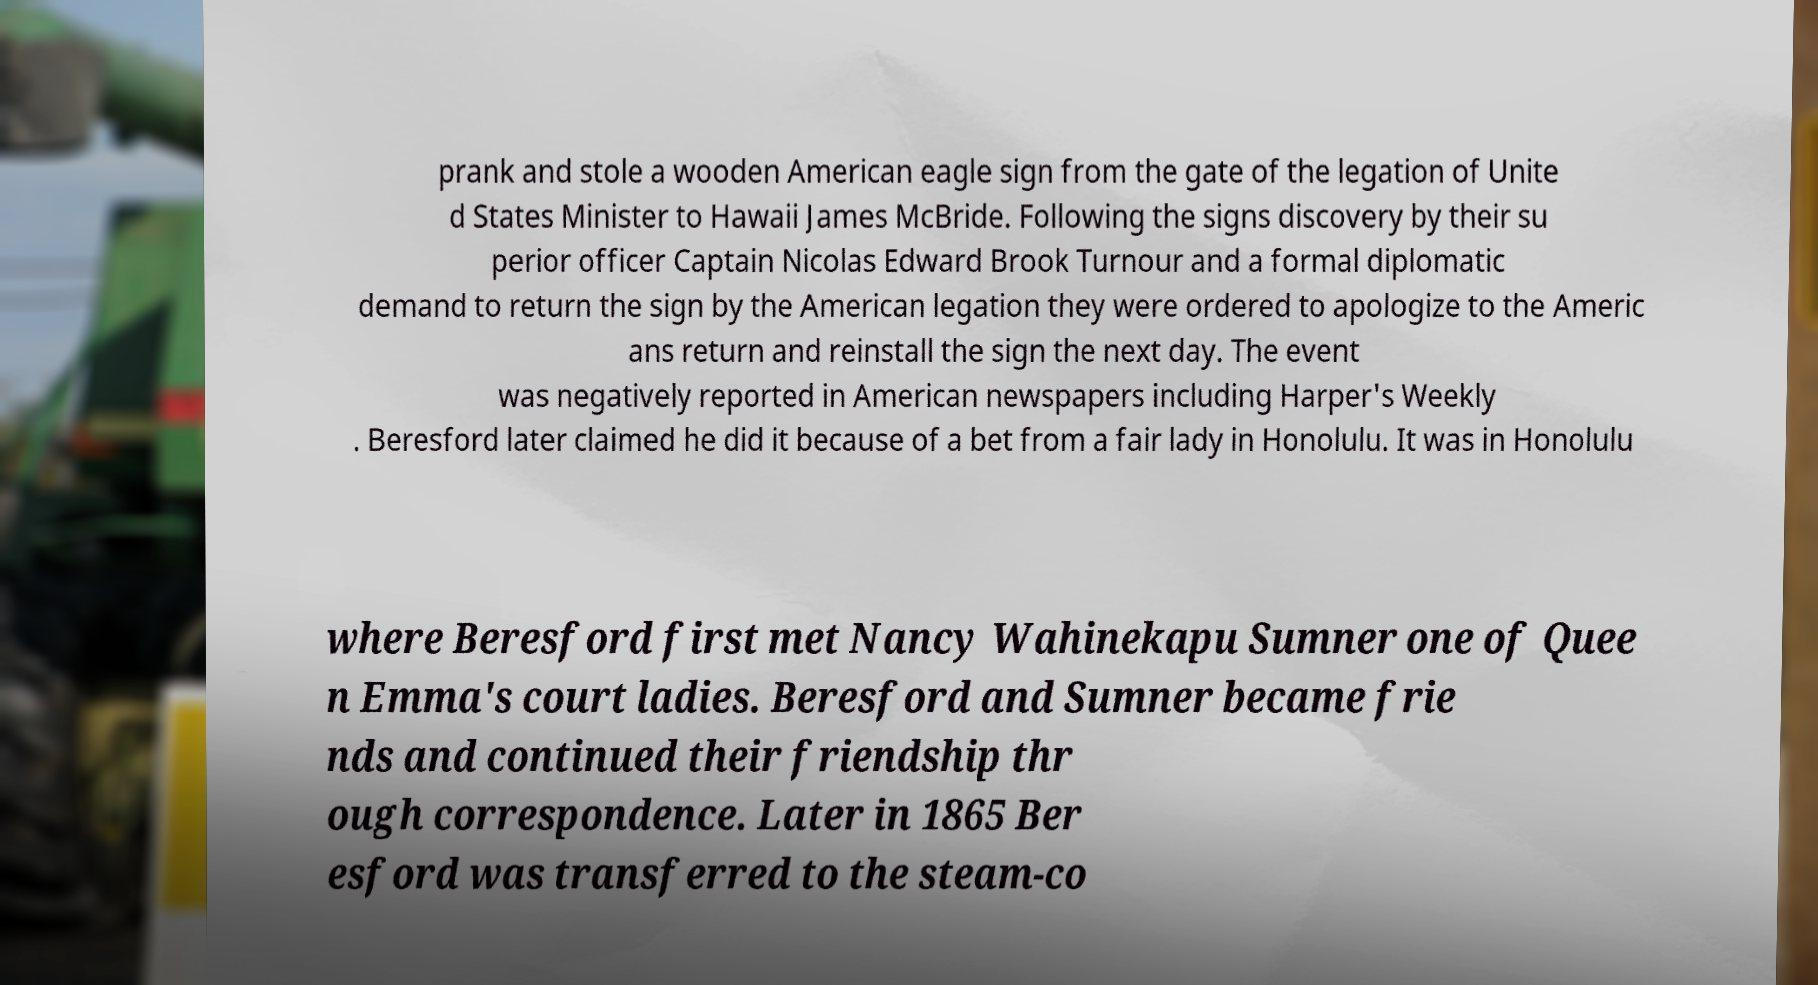What messages or text are displayed in this image? I need them in a readable, typed format. prank and stole a wooden American eagle sign from the gate of the legation of Unite d States Minister to Hawaii James McBride. Following the signs discovery by their su perior officer Captain Nicolas Edward Brook Turnour and a formal diplomatic demand to return the sign by the American legation they were ordered to apologize to the Americ ans return and reinstall the sign the next day. The event was negatively reported in American newspapers including Harper's Weekly . Beresford later claimed he did it because of a bet from a fair lady in Honolulu. It was in Honolulu where Beresford first met Nancy Wahinekapu Sumner one of Quee n Emma's court ladies. Beresford and Sumner became frie nds and continued their friendship thr ough correspondence. Later in 1865 Ber esford was transferred to the steam-co 